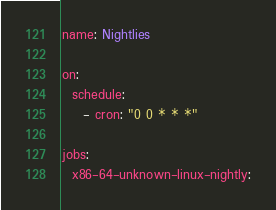Convert code to text. <code><loc_0><loc_0><loc_500><loc_500><_YAML_>name: Nightlies

on:
  schedule:
    - cron: "0 0 * * *"

jobs:
  x86-64-unknown-linux-nightly:</code> 